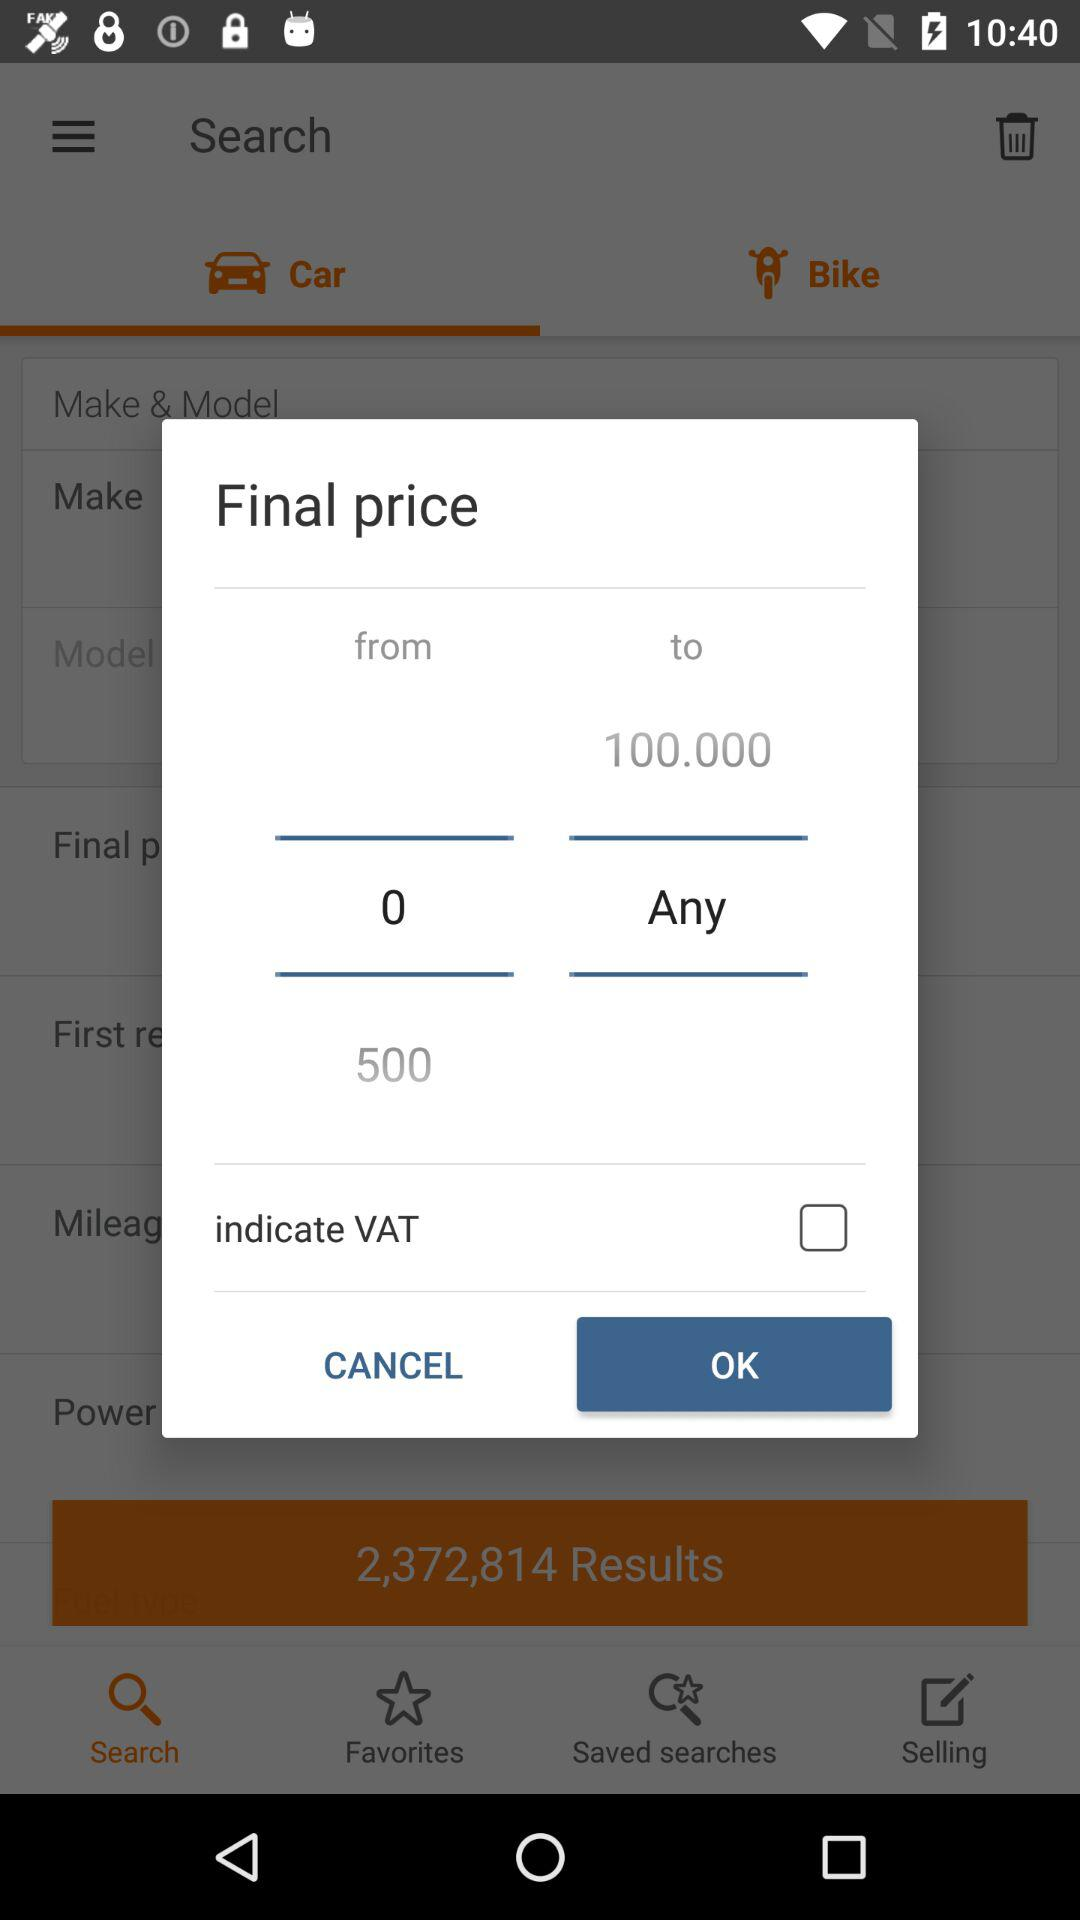Which tab is currently selected? The selected tab is "Car". 